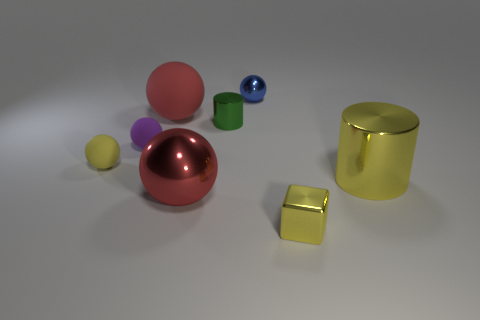Subtract all green cylinders. How many cylinders are left? 1 Subtract all large red spheres. How many spheres are left? 3 Subtract 0 green cubes. How many objects are left? 8 Subtract all spheres. How many objects are left? 3 Subtract 2 cylinders. How many cylinders are left? 0 Subtract all red cubes. Subtract all yellow spheres. How many cubes are left? 1 Subtract all yellow balls. How many yellow cylinders are left? 1 Subtract all tiny spheres. Subtract all balls. How many objects are left? 0 Add 7 red objects. How many red objects are left? 9 Add 6 big purple blocks. How many big purple blocks exist? 6 